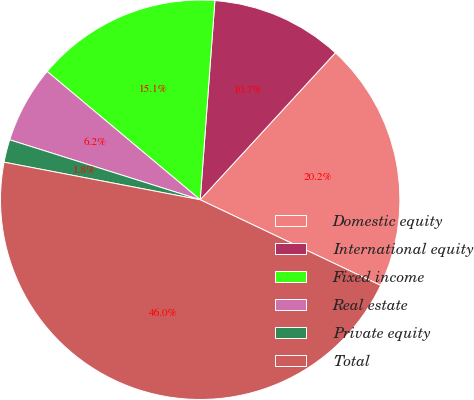Convert chart to OTSL. <chart><loc_0><loc_0><loc_500><loc_500><pie_chart><fcel>Domestic equity<fcel>International equity<fcel>Fixed income<fcel>Real estate<fcel>Private equity<fcel>Total<nl><fcel>20.22%<fcel>10.66%<fcel>15.07%<fcel>6.25%<fcel>1.84%<fcel>45.96%<nl></chart> 